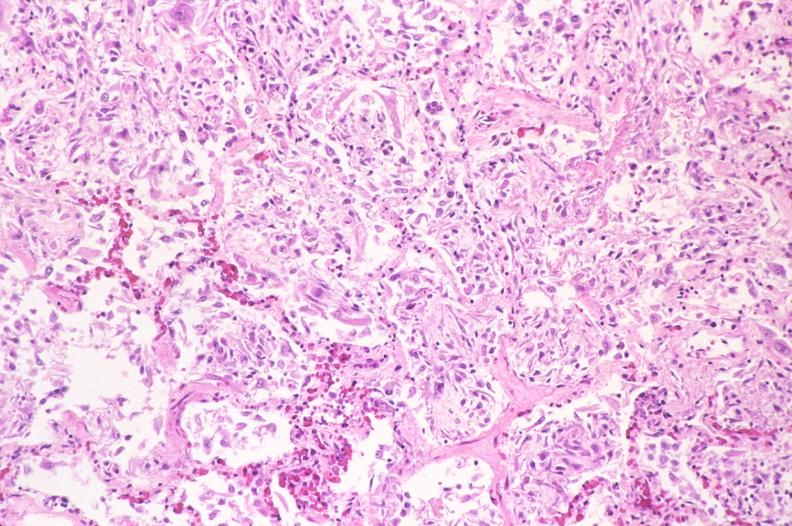s gross photo of tumor in this file present?
Answer the question using a single word or phrase. No 